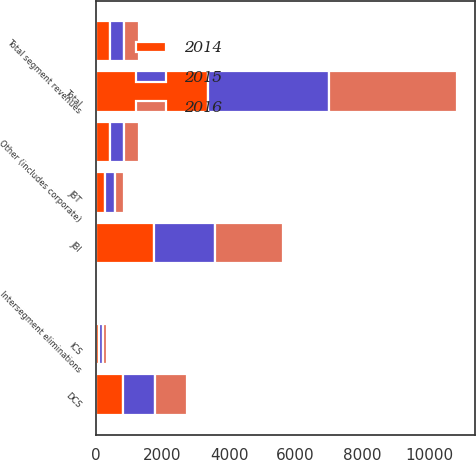Convert chart. <chart><loc_0><loc_0><loc_500><loc_500><stacked_bar_chart><ecel><fcel>JBI<fcel>DCS<fcel>ICS<fcel>JBT<fcel>Other (includes corporate)<fcel>Total<fcel>Total segment revenues<fcel>Intersegment eliminations<nl><fcel>2016<fcel>2032<fcel>951<fcel>136<fcel>279<fcel>431<fcel>3829<fcel>431<fcel>14<nl><fcel>2015<fcel>1848<fcel>949<fcel>99<fcel>286<fcel>448<fcel>3630<fcel>431<fcel>13<nl><fcel>2014<fcel>1733<fcel>832<fcel>106<fcel>289<fcel>414<fcel>3374<fcel>431<fcel>20<nl></chart> 